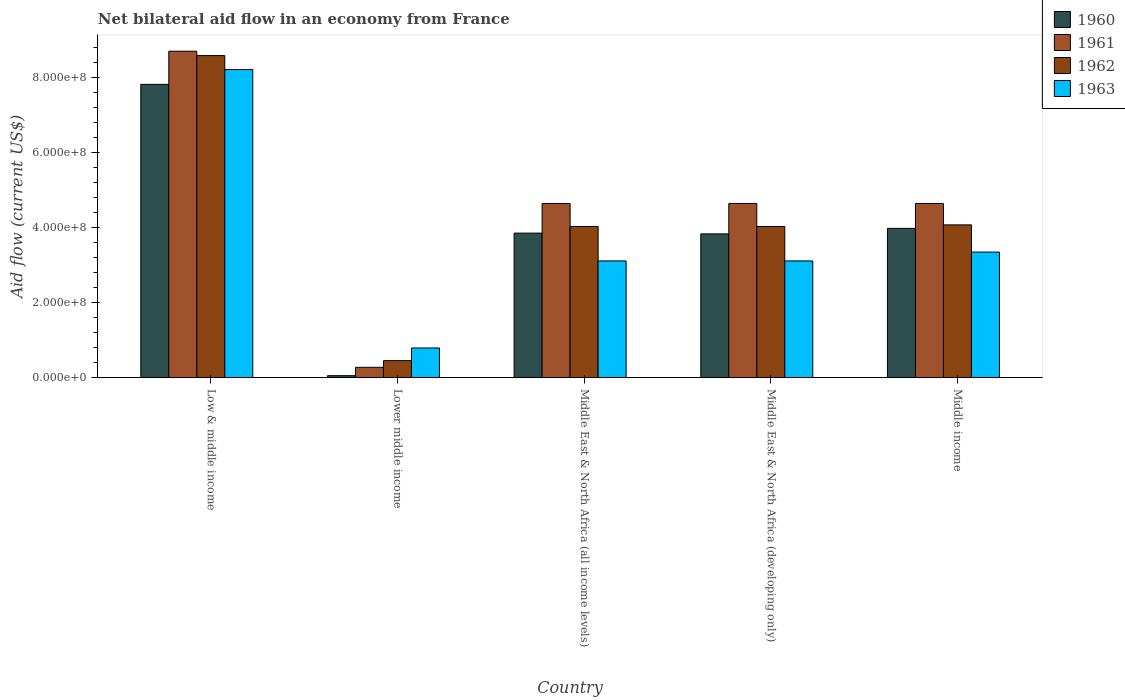How many groups of bars are there?
Make the answer very short. 5. Are the number of bars per tick equal to the number of legend labels?
Provide a succinct answer. Yes. How many bars are there on the 1st tick from the left?
Your response must be concise. 4. How many bars are there on the 1st tick from the right?
Offer a terse response. 4. What is the label of the 2nd group of bars from the left?
Provide a short and direct response. Lower middle income. In how many cases, is the number of bars for a given country not equal to the number of legend labels?
Your answer should be very brief. 0. What is the net bilateral aid flow in 1960 in Middle East & North Africa (developing only)?
Keep it short and to the point. 3.83e+08. Across all countries, what is the maximum net bilateral aid flow in 1961?
Your response must be concise. 8.70e+08. Across all countries, what is the minimum net bilateral aid flow in 1961?
Provide a short and direct response. 2.76e+07. In which country was the net bilateral aid flow in 1962 minimum?
Provide a short and direct response. Lower middle income. What is the total net bilateral aid flow in 1961 in the graph?
Ensure brevity in your answer.  2.29e+09. What is the difference between the net bilateral aid flow in 1960 in Lower middle income and that in Middle income?
Your answer should be compact. -3.92e+08. What is the difference between the net bilateral aid flow in 1963 in Low & middle income and the net bilateral aid flow in 1960 in Lower middle income?
Your response must be concise. 8.16e+08. What is the average net bilateral aid flow in 1961 per country?
Provide a succinct answer. 4.58e+08. What is the difference between the net bilateral aid flow of/in 1960 and net bilateral aid flow of/in 1963 in Middle East & North Africa (all income levels)?
Keep it short and to the point. 7.41e+07. What is the ratio of the net bilateral aid flow in 1962 in Low & middle income to that in Middle income?
Offer a terse response. 2.11. What is the difference between the highest and the second highest net bilateral aid flow in 1962?
Provide a succinct answer. 4.51e+08. What is the difference between the highest and the lowest net bilateral aid flow in 1960?
Provide a succinct answer. 7.76e+08. In how many countries, is the net bilateral aid flow in 1962 greater than the average net bilateral aid flow in 1962 taken over all countries?
Make the answer very short. 1. Is the sum of the net bilateral aid flow in 1961 in Middle East & North Africa (all income levels) and Middle East & North Africa (developing only) greater than the maximum net bilateral aid flow in 1962 across all countries?
Your answer should be compact. Yes. Is it the case that in every country, the sum of the net bilateral aid flow in 1963 and net bilateral aid flow in 1961 is greater than the sum of net bilateral aid flow in 1960 and net bilateral aid flow in 1962?
Make the answer very short. No. What is the difference between two consecutive major ticks on the Y-axis?
Make the answer very short. 2.00e+08. Are the values on the major ticks of Y-axis written in scientific E-notation?
Keep it short and to the point. Yes. Does the graph contain grids?
Provide a succinct answer. No. Where does the legend appear in the graph?
Your response must be concise. Top right. How are the legend labels stacked?
Your answer should be very brief. Vertical. What is the title of the graph?
Your answer should be compact. Net bilateral aid flow in an economy from France. What is the Aid flow (current US$) in 1960 in Low & middle income?
Your response must be concise. 7.82e+08. What is the Aid flow (current US$) of 1961 in Low & middle income?
Keep it short and to the point. 8.70e+08. What is the Aid flow (current US$) of 1962 in Low & middle income?
Make the answer very short. 8.58e+08. What is the Aid flow (current US$) in 1963 in Low & middle income?
Make the answer very short. 8.21e+08. What is the Aid flow (current US$) of 1960 in Lower middle income?
Make the answer very short. 5.30e+06. What is the Aid flow (current US$) of 1961 in Lower middle income?
Keep it short and to the point. 2.76e+07. What is the Aid flow (current US$) in 1962 in Lower middle income?
Offer a terse response. 4.54e+07. What is the Aid flow (current US$) in 1963 in Lower middle income?
Make the answer very short. 7.91e+07. What is the Aid flow (current US$) in 1960 in Middle East & North Africa (all income levels)?
Make the answer very short. 3.85e+08. What is the Aid flow (current US$) in 1961 in Middle East & North Africa (all income levels)?
Provide a short and direct response. 4.64e+08. What is the Aid flow (current US$) in 1962 in Middle East & North Africa (all income levels)?
Your answer should be very brief. 4.03e+08. What is the Aid flow (current US$) of 1963 in Middle East & North Africa (all income levels)?
Give a very brief answer. 3.11e+08. What is the Aid flow (current US$) in 1960 in Middle East & North Africa (developing only)?
Your response must be concise. 3.83e+08. What is the Aid flow (current US$) of 1961 in Middle East & North Africa (developing only)?
Give a very brief answer. 4.64e+08. What is the Aid flow (current US$) in 1962 in Middle East & North Africa (developing only)?
Your answer should be compact. 4.03e+08. What is the Aid flow (current US$) in 1963 in Middle East & North Africa (developing only)?
Provide a succinct answer. 3.11e+08. What is the Aid flow (current US$) of 1960 in Middle income?
Ensure brevity in your answer.  3.98e+08. What is the Aid flow (current US$) of 1961 in Middle income?
Ensure brevity in your answer.  4.64e+08. What is the Aid flow (current US$) in 1962 in Middle income?
Provide a succinct answer. 4.07e+08. What is the Aid flow (current US$) of 1963 in Middle income?
Offer a terse response. 3.35e+08. Across all countries, what is the maximum Aid flow (current US$) in 1960?
Your response must be concise. 7.82e+08. Across all countries, what is the maximum Aid flow (current US$) of 1961?
Offer a terse response. 8.70e+08. Across all countries, what is the maximum Aid flow (current US$) of 1962?
Offer a terse response. 8.58e+08. Across all countries, what is the maximum Aid flow (current US$) in 1963?
Your answer should be compact. 8.21e+08. Across all countries, what is the minimum Aid flow (current US$) in 1960?
Your answer should be very brief. 5.30e+06. Across all countries, what is the minimum Aid flow (current US$) of 1961?
Make the answer very short. 2.76e+07. Across all countries, what is the minimum Aid flow (current US$) of 1962?
Ensure brevity in your answer.  4.54e+07. Across all countries, what is the minimum Aid flow (current US$) of 1963?
Your answer should be very brief. 7.91e+07. What is the total Aid flow (current US$) of 1960 in the graph?
Make the answer very short. 1.95e+09. What is the total Aid flow (current US$) of 1961 in the graph?
Offer a very short reply. 2.29e+09. What is the total Aid flow (current US$) of 1962 in the graph?
Your answer should be very brief. 2.12e+09. What is the total Aid flow (current US$) in 1963 in the graph?
Offer a terse response. 1.86e+09. What is the difference between the Aid flow (current US$) in 1960 in Low & middle income and that in Lower middle income?
Keep it short and to the point. 7.76e+08. What is the difference between the Aid flow (current US$) in 1961 in Low & middle income and that in Lower middle income?
Keep it short and to the point. 8.42e+08. What is the difference between the Aid flow (current US$) of 1962 in Low & middle income and that in Lower middle income?
Your answer should be compact. 8.13e+08. What is the difference between the Aid flow (current US$) in 1963 in Low & middle income and that in Lower middle income?
Make the answer very short. 7.42e+08. What is the difference between the Aid flow (current US$) of 1960 in Low & middle income and that in Middle East & North Africa (all income levels)?
Provide a short and direct response. 3.96e+08. What is the difference between the Aid flow (current US$) in 1961 in Low & middle income and that in Middle East & North Africa (all income levels)?
Provide a short and direct response. 4.06e+08. What is the difference between the Aid flow (current US$) in 1962 in Low & middle income and that in Middle East & North Africa (all income levels)?
Offer a terse response. 4.55e+08. What is the difference between the Aid flow (current US$) of 1963 in Low & middle income and that in Middle East & North Africa (all income levels)?
Give a very brief answer. 5.10e+08. What is the difference between the Aid flow (current US$) in 1960 in Low & middle income and that in Middle East & North Africa (developing only)?
Your answer should be very brief. 3.98e+08. What is the difference between the Aid flow (current US$) of 1961 in Low & middle income and that in Middle East & North Africa (developing only)?
Your answer should be very brief. 4.06e+08. What is the difference between the Aid flow (current US$) in 1962 in Low & middle income and that in Middle East & North Africa (developing only)?
Provide a succinct answer. 4.55e+08. What is the difference between the Aid flow (current US$) in 1963 in Low & middle income and that in Middle East & North Africa (developing only)?
Your answer should be compact. 5.10e+08. What is the difference between the Aid flow (current US$) of 1960 in Low & middle income and that in Middle income?
Offer a very short reply. 3.84e+08. What is the difference between the Aid flow (current US$) in 1961 in Low & middle income and that in Middle income?
Provide a short and direct response. 4.06e+08. What is the difference between the Aid flow (current US$) of 1962 in Low & middle income and that in Middle income?
Make the answer very short. 4.51e+08. What is the difference between the Aid flow (current US$) of 1963 in Low & middle income and that in Middle income?
Offer a terse response. 4.86e+08. What is the difference between the Aid flow (current US$) in 1960 in Lower middle income and that in Middle East & North Africa (all income levels)?
Keep it short and to the point. -3.80e+08. What is the difference between the Aid flow (current US$) of 1961 in Lower middle income and that in Middle East & North Africa (all income levels)?
Offer a very short reply. -4.37e+08. What is the difference between the Aid flow (current US$) of 1962 in Lower middle income and that in Middle East & North Africa (all income levels)?
Provide a short and direct response. -3.58e+08. What is the difference between the Aid flow (current US$) of 1963 in Lower middle income and that in Middle East & North Africa (all income levels)?
Your response must be concise. -2.32e+08. What is the difference between the Aid flow (current US$) in 1960 in Lower middle income and that in Middle East & North Africa (developing only)?
Keep it short and to the point. -3.78e+08. What is the difference between the Aid flow (current US$) in 1961 in Lower middle income and that in Middle East & North Africa (developing only)?
Offer a very short reply. -4.37e+08. What is the difference between the Aid flow (current US$) of 1962 in Lower middle income and that in Middle East & North Africa (developing only)?
Your answer should be very brief. -3.58e+08. What is the difference between the Aid flow (current US$) of 1963 in Lower middle income and that in Middle East & North Africa (developing only)?
Your answer should be very brief. -2.32e+08. What is the difference between the Aid flow (current US$) of 1960 in Lower middle income and that in Middle income?
Keep it short and to the point. -3.92e+08. What is the difference between the Aid flow (current US$) in 1961 in Lower middle income and that in Middle income?
Ensure brevity in your answer.  -4.37e+08. What is the difference between the Aid flow (current US$) of 1962 in Lower middle income and that in Middle income?
Keep it short and to the point. -3.62e+08. What is the difference between the Aid flow (current US$) in 1963 in Lower middle income and that in Middle income?
Offer a terse response. -2.56e+08. What is the difference between the Aid flow (current US$) in 1963 in Middle East & North Africa (all income levels) and that in Middle East & North Africa (developing only)?
Your response must be concise. 0. What is the difference between the Aid flow (current US$) of 1960 in Middle East & North Africa (all income levels) and that in Middle income?
Your response must be concise. -1.26e+07. What is the difference between the Aid flow (current US$) of 1961 in Middle East & North Africa (all income levels) and that in Middle income?
Ensure brevity in your answer.  0. What is the difference between the Aid flow (current US$) of 1962 in Middle East & North Africa (all income levels) and that in Middle income?
Offer a terse response. -4.20e+06. What is the difference between the Aid flow (current US$) of 1963 in Middle East & North Africa (all income levels) and that in Middle income?
Provide a succinct answer. -2.36e+07. What is the difference between the Aid flow (current US$) of 1960 in Middle East & North Africa (developing only) and that in Middle income?
Your answer should be very brief. -1.46e+07. What is the difference between the Aid flow (current US$) of 1961 in Middle East & North Africa (developing only) and that in Middle income?
Make the answer very short. 0. What is the difference between the Aid flow (current US$) in 1962 in Middle East & North Africa (developing only) and that in Middle income?
Your response must be concise. -4.20e+06. What is the difference between the Aid flow (current US$) in 1963 in Middle East & North Africa (developing only) and that in Middle income?
Provide a succinct answer. -2.36e+07. What is the difference between the Aid flow (current US$) of 1960 in Low & middle income and the Aid flow (current US$) of 1961 in Lower middle income?
Offer a terse response. 7.54e+08. What is the difference between the Aid flow (current US$) of 1960 in Low & middle income and the Aid flow (current US$) of 1962 in Lower middle income?
Give a very brief answer. 7.36e+08. What is the difference between the Aid flow (current US$) in 1960 in Low & middle income and the Aid flow (current US$) in 1963 in Lower middle income?
Ensure brevity in your answer.  7.02e+08. What is the difference between the Aid flow (current US$) of 1961 in Low & middle income and the Aid flow (current US$) of 1962 in Lower middle income?
Offer a terse response. 8.25e+08. What is the difference between the Aid flow (current US$) of 1961 in Low & middle income and the Aid flow (current US$) of 1963 in Lower middle income?
Offer a terse response. 7.91e+08. What is the difference between the Aid flow (current US$) of 1962 in Low & middle income and the Aid flow (current US$) of 1963 in Lower middle income?
Make the answer very short. 7.79e+08. What is the difference between the Aid flow (current US$) in 1960 in Low & middle income and the Aid flow (current US$) in 1961 in Middle East & North Africa (all income levels)?
Your answer should be compact. 3.17e+08. What is the difference between the Aid flow (current US$) of 1960 in Low & middle income and the Aid flow (current US$) of 1962 in Middle East & North Africa (all income levels)?
Offer a terse response. 3.79e+08. What is the difference between the Aid flow (current US$) of 1960 in Low & middle income and the Aid flow (current US$) of 1963 in Middle East & North Africa (all income levels)?
Offer a very short reply. 4.70e+08. What is the difference between the Aid flow (current US$) of 1961 in Low & middle income and the Aid flow (current US$) of 1962 in Middle East & North Africa (all income levels)?
Keep it short and to the point. 4.67e+08. What is the difference between the Aid flow (current US$) in 1961 in Low & middle income and the Aid flow (current US$) in 1963 in Middle East & North Africa (all income levels)?
Give a very brief answer. 5.59e+08. What is the difference between the Aid flow (current US$) in 1962 in Low & middle income and the Aid flow (current US$) in 1963 in Middle East & North Africa (all income levels)?
Offer a terse response. 5.47e+08. What is the difference between the Aid flow (current US$) of 1960 in Low & middle income and the Aid flow (current US$) of 1961 in Middle East & North Africa (developing only)?
Your answer should be compact. 3.17e+08. What is the difference between the Aid flow (current US$) in 1960 in Low & middle income and the Aid flow (current US$) in 1962 in Middle East & North Africa (developing only)?
Your answer should be compact. 3.79e+08. What is the difference between the Aid flow (current US$) in 1960 in Low & middle income and the Aid flow (current US$) in 1963 in Middle East & North Africa (developing only)?
Ensure brevity in your answer.  4.70e+08. What is the difference between the Aid flow (current US$) of 1961 in Low & middle income and the Aid flow (current US$) of 1962 in Middle East & North Africa (developing only)?
Your answer should be very brief. 4.67e+08. What is the difference between the Aid flow (current US$) of 1961 in Low & middle income and the Aid flow (current US$) of 1963 in Middle East & North Africa (developing only)?
Give a very brief answer. 5.59e+08. What is the difference between the Aid flow (current US$) of 1962 in Low & middle income and the Aid flow (current US$) of 1963 in Middle East & North Africa (developing only)?
Give a very brief answer. 5.47e+08. What is the difference between the Aid flow (current US$) in 1960 in Low & middle income and the Aid flow (current US$) in 1961 in Middle income?
Your response must be concise. 3.17e+08. What is the difference between the Aid flow (current US$) in 1960 in Low & middle income and the Aid flow (current US$) in 1962 in Middle income?
Offer a very short reply. 3.74e+08. What is the difference between the Aid flow (current US$) of 1960 in Low & middle income and the Aid flow (current US$) of 1963 in Middle income?
Your answer should be compact. 4.47e+08. What is the difference between the Aid flow (current US$) in 1961 in Low & middle income and the Aid flow (current US$) in 1962 in Middle income?
Give a very brief answer. 4.63e+08. What is the difference between the Aid flow (current US$) in 1961 in Low & middle income and the Aid flow (current US$) in 1963 in Middle income?
Offer a very short reply. 5.35e+08. What is the difference between the Aid flow (current US$) in 1962 in Low & middle income and the Aid flow (current US$) in 1963 in Middle income?
Offer a very short reply. 5.24e+08. What is the difference between the Aid flow (current US$) of 1960 in Lower middle income and the Aid flow (current US$) of 1961 in Middle East & North Africa (all income levels)?
Offer a very short reply. -4.59e+08. What is the difference between the Aid flow (current US$) of 1960 in Lower middle income and the Aid flow (current US$) of 1962 in Middle East & North Africa (all income levels)?
Keep it short and to the point. -3.98e+08. What is the difference between the Aid flow (current US$) of 1960 in Lower middle income and the Aid flow (current US$) of 1963 in Middle East & North Africa (all income levels)?
Give a very brief answer. -3.06e+08. What is the difference between the Aid flow (current US$) in 1961 in Lower middle income and the Aid flow (current US$) in 1962 in Middle East & North Africa (all income levels)?
Offer a very short reply. -3.75e+08. What is the difference between the Aid flow (current US$) in 1961 in Lower middle income and the Aid flow (current US$) in 1963 in Middle East & North Africa (all income levels)?
Your answer should be compact. -2.84e+08. What is the difference between the Aid flow (current US$) in 1962 in Lower middle income and the Aid flow (current US$) in 1963 in Middle East & North Africa (all income levels)?
Provide a short and direct response. -2.66e+08. What is the difference between the Aid flow (current US$) of 1960 in Lower middle income and the Aid flow (current US$) of 1961 in Middle East & North Africa (developing only)?
Your answer should be compact. -4.59e+08. What is the difference between the Aid flow (current US$) in 1960 in Lower middle income and the Aid flow (current US$) in 1962 in Middle East & North Africa (developing only)?
Your answer should be very brief. -3.98e+08. What is the difference between the Aid flow (current US$) of 1960 in Lower middle income and the Aid flow (current US$) of 1963 in Middle East & North Africa (developing only)?
Offer a very short reply. -3.06e+08. What is the difference between the Aid flow (current US$) in 1961 in Lower middle income and the Aid flow (current US$) in 1962 in Middle East & North Africa (developing only)?
Ensure brevity in your answer.  -3.75e+08. What is the difference between the Aid flow (current US$) in 1961 in Lower middle income and the Aid flow (current US$) in 1963 in Middle East & North Africa (developing only)?
Provide a succinct answer. -2.84e+08. What is the difference between the Aid flow (current US$) of 1962 in Lower middle income and the Aid flow (current US$) of 1963 in Middle East & North Africa (developing only)?
Provide a succinct answer. -2.66e+08. What is the difference between the Aid flow (current US$) in 1960 in Lower middle income and the Aid flow (current US$) in 1961 in Middle income?
Ensure brevity in your answer.  -4.59e+08. What is the difference between the Aid flow (current US$) of 1960 in Lower middle income and the Aid flow (current US$) of 1962 in Middle income?
Make the answer very short. -4.02e+08. What is the difference between the Aid flow (current US$) of 1960 in Lower middle income and the Aid flow (current US$) of 1963 in Middle income?
Your answer should be very brief. -3.29e+08. What is the difference between the Aid flow (current US$) in 1961 in Lower middle income and the Aid flow (current US$) in 1962 in Middle income?
Your answer should be compact. -3.80e+08. What is the difference between the Aid flow (current US$) of 1961 in Lower middle income and the Aid flow (current US$) of 1963 in Middle income?
Your response must be concise. -3.07e+08. What is the difference between the Aid flow (current US$) in 1962 in Lower middle income and the Aid flow (current US$) in 1963 in Middle income?
Your answer should be compact. -2.89e+08. What is the difference between the Aid flow (current US$) in 1960 in Middle East & North Africa (all income levels) and the Aid flow (current US$) in 1961 in Middle East & North Africa (developing only)?
Provide a succinct answer. -7.90e+07. What is the difference between the Aid flow (current US$) in 1960 in Middle East & North Africa (all income levels) and the Aid flow (current US$) in 1962 in Middle East & North Africa (developing only)?
Your answer should be very brief. -1.78e+07. What is the difference between the Aid flow (current US$) in 1960 in Middle East & North Africa (all income levels) and the Aid flow (current US$) in 1963 in Middle East & North Africa (developing only)?
Offer a very short reply. 7.41e+07. What is the difference between the Aid flow (current US$) of 1961 in Middle East & North Africa (all income levels) and the Aid flow (current US$) of 1962 in Middle East & North Africa (developing only)?
Offer a terse response. 6.12e+07. What is the difference between the Aid flow (current US$) of 1961 in Middle East & North Africa (all income levels) and the Aid flow (current US$) of 1963 in Middle East & North Africa (developing only)?
Make the answer very short. 1.53e+08. What is the difference between the Aid flow (current US$) of 1962 in Middle East & North Africa (all income levels) and the Aid flow (current US$) of 1963 in Middle East & North Africa (developing only)?
Ensure brevity in your answer.  9.19e+07. What is the difference between the Aid flow (current US$) in 1960 in Middle East & North Africa (all income levels) and the Aid flow (current US$) in 1961 in Middle income?
Provide a short and direct response. -7.90e+07. What is the difference between the Aid flow (current US$) in 1960 in Middle East & North Africa (all income levels) and the Aid flow (current US$) in 1962 in Middle income?
Ensure brevity in your answer.  -2.20e+07. What is the difference between the Aid flow (current US$) of 1960 in Middle East & North Africa (all income levels) and the Aid flow (current US$) of 1963 in Middle income?
Offer a terse response. 5.05e+07. What is the difference between the Aid flow (current US$) of 1961 in Middle East & North Africa (all income levels) and the Aid flow (current US$) of 1962 in Middle income?
Make the answer very short. 5.70e+07. What is the difference between the Aid flow (current US$) of 1961 in Middle East & North Africa (all income levels) and the Aid flow (current US$) of 1963 in Middle income?
Your answer should be very brief. 1.30e+08. What is the difference between the Aid flow (current US$) of 1962 in Middle East & North Africa (all income levels) and the Aid flow (current US$) of 1963 in Middle income?
Your answer should be very brief. 6.83e+07. What is the difference between the Aid flow (current US$) of 1960 in Middle East & North Africa (developing only) and the Aid flow (current US$) of 1961 in Middle income?
Ensure brevity in your answer.  -8.10e+07. What is the difference between the Aid flow (current US$) in 1960 in Middle East & North Africa (developing only) and the Aid flow (current US$) in 1962 in Middle income?
Your response must be concise. -2.40e+07. What is the difference between the Aid flow (current US$) in 1960 in Middle East & North Africa (developing only) and the Aid flow (current US$) in 1963 in Middle income?
Keep it short and to the point. 4.85e+07. What is the difference between the Aid flow (current US$) in 1961 in Middle East & North Africa (developing only) and the Aid flow (current US$) in 1962 in Middle income?
Offer a very short reply. 5.70e+07. What is the difference between the Aid flow (current US$) of 1961 in Middle East & North Africa (developing only) and the Aid flow (current US$) of 1963 in Middle income?
Offer a very short reply. 1.30e+08. What is the difference between the Aid flow (current US$) in 1962 in Middle East & North Africa (developing only) and the Aid flow (current US$) in 1963 in Middle income?
Your answer should be compact. 6.83e+07. What is the average Aid flow (current US$) of 1960 per country?
Your response must be concise. 3.91e+08. What is the average Aid flow (current US$) of 1961 per country?
Your response must be concise. 4.58e+08. What is the average Aid flow (current US$) in 1962 per country?
Ensure brevity in your answer.  4.23e+08. What is the average Aid flow (current US$) in 1963 per country?
Make the answer very short. 3.71e+08. What is the difference between the Aid flow (current US$) in 1960 and Aid flow (current US$) in 1961 in Low & middle income?
Give a very brief answer. -8.84e+07. What is the difference between the Aid flow (current US$) of 1960 and Aid flow (current US$) of 1962 in Low & middle income?
Offer a terse response. -7.67e+07. What is the difference between the Aid flow (current US$) in 1960 and Aid flow (current US$) in 1963 in Low & middle income?
Your answer should be compact. -3.95e+07. What is the difference between the Aid flow (current US$) in 1961 and Aid flow (current US$) in 1962 in Low & middle income?
Make the answer very short. 1.17e+07. What is the difference between the Aid flow (current US$) of 1961 and Aid flow (current US$) of 1963 in Low & middle income?
Offer a very short reply. 4.89e+07. What is the difference between the Aid flow (current US$) of 1962 and Aid flow (current US$) of 1963 in Low & middle income?
Offer a terse response. 3.72e+07. What is the difference between the Aid flow (current US$) of 1960 and Aid flow (current US$) of 1961 in Lower middle income?
Make the answer very short. -2.23e+07. What is the difference between the Aid flow (current US$) in 1960 and Aid flow (current US$) in 1962 in Lower middle income?
Ensure brevity in your answer.  -4.01e+07. What is the difference between the Aid flow (current US$) of 1960 and Aid flow (current US$) of 1963 in Lower middle income?
Give a very brief answer. -7.38e+07. What is the difference between the Aid flow (current US$) of 1961 and Aid flow (current US$) of 1962 in Lower middle income?
Give a very brief answer. -1.78e+07. What is the difference between the Aid flow (current US$) of 1961 and Aid flow (current US$) of 1963 in Lower middle income?
Make the answer very short. -5.15e+07. What is the difference between the Aid flow (current US$) in 1962 and Aid flow (current US$) in 1963 in Lower middle income?
Your answer should be compact. -3.37e+07. What is the difference between the Aid flow (current US$) of 1960 and Aid flow (current US$) of 1961 in Middle East & North Africa (all income levels)?
Your answer should be very brief. -7.90e+07. What is the difference between the Aid flow (current US$) in 1960 and Aid flow (current US$) in 1962 in Middle East & North Africa (all income levels)?
Make the answer very short. -1.78e+07. What is the difference between the Aid flow (current US$) in 1960 and Aid flow (current US$) in 1963 in Middle East & North Africa (all income levels)?
Your answer should be compact. 7.41e+07. What is the difference between the Aid flow (current US$) of 1961 and Aid flow (current US$) of 1962 in Middle East & North Africa (all income levels)?
Provide a succinct answer. 6.12e+07. What is the difference between the Aid flow (current US$) of 1961 and Aid flow (current US$) of 1963 in Middle East & North Africa (all income levels)?
Give a very brief answer. 1.53e+08. What is the difference between the Aid flow (current US$) in 1962 and Aid flow (current US$) in 1963 in Middle East & North Africa (all income levels)?
Make the answer very short. 9.19e+07. What is the difference between the Aid flow (current US$) in 1960 and Aid flow (current US$) in 1961 in Middle East & North Africa (developing only)?
Your answer should be compact. -8.10e+07. What is the difference between the Aid flow (current US$) in 1960 and Aid flow (current US$) in 1962 in Middle East & North Africa (developing only)?
Provide a short and direct response. -1.98e+07. What is the difference between the Aid flow (current US$) of 1960 and Aid flow (current US$) of 1963 in Middle East & North Africa (developing only)?
Ensure brevity in your answer.  7.21e+07. What is the difference between the Aid flow (current US$) of 1961 and Aid flow (current US$) of 1962 in Middle East & North Africa (developing only)?
Your response must be concise. 6.12e+07. What is the difference between the Aid flow (current US$) of 1961 and Aid flow (current US$) of 1963 in Middle East & North Africa (developing only)?
Ensure brevity in your answer.  1.53e+08. What is the difference between the Aid flow (current US$) of 1962 and Aid flow (current US$) of 1963 in Middle East & North Africa (developing only)?
Offer a terse response. 9.19e+07. What is the difference between the Aid flow (current US$) of 1960 and Aid flow (current US$) of 1961 in Middle income?
Offer a terse response. -6.64e+07. What is the difference between the Aid flow (current US$) in 1960 and Aid flow (current US$) in 1962 in Middle income?
Make the answer very short. -9.40e+06. What is the difference between the Aid flow (current US$) in 1960 and Aid flow (current US$) in 1963 in Middle income?
Give a very brief answer. 6.31e+07. What is the difference between the Aid flow (current US$) in 1961 and Aid flow (current US$) in 1962 in Middle income?
Make the answer very short. 5.70e+07. What is the difference between the Aid flow (current US$) of 1961 and Aid flow (current US$) of 1963 in Middle income?
Make the answer very short. 1.30e+08. What is the difference between the Aid flow (current US$) in 1962 and Aid flow (current US$) in 1963 in Middle income?
Your response must be concise. 7.25e+07. What is the ratio of the Aid flow (current US$) of 1960 in Low & middle income to that in Lower middle income?
Offer a very short reply. 147.47. What is the ratio of the Aid flow (current US$) of 1961 in Low & middle income to that in Lower middle income?
Your answer should be compact. 31.52. What is the ratio of the Aid flow (current US$) of 1962 in Low & middle income to that in Lower middle income?
Make the answer very short. 18.91. What is the ratio of the Aid flow (current US$) of 1963 in Low & middle income to that in Lower middle income?
Offer a very short reply. 10.38. What is the ratio of the Aid flow (current US$) of 1960 in Low & middle income to that in Middle East & North Africa (all income levels)?
Your answer should be compact. 2.03. What is the ratio of the Aid flow (current US$) of 1961 in Low & middle income to that in Middle East & North Africa (all income levels)?
Offer a terse response. 1.87. What is the ratio of the Aid flow (current US$) in 1962 in Low & middle income to that in Middle East & North Africa (all income levels)?
Ensure brevity in your answer.  2.13. What is the ratio of the Aid flow (current US$) of 1963 in Low & middle income to that in Middle East & North Africa (all income levels)?
Your answer should be very brief. 2.64. What is the ratio of the Aid flow (current US$) of 1960 in Low & middle income to that in Middle East & North Africa (developing only)?
Offer a very short reply. 2.04. What is the ratio of the Aid flow (current US$) of 1961 in Low & middle income to that in Middle East & North Africa (developing only)?
Make the answer very short. 1.87. What is the ratio of the Aid flow (current US$) of 1962 in Low & middle income to that in Middle East & North Africa (developing only)?
Ensure brevity in your answer.  2.13. What is the ratio of the Aid flow (current US$) of 1963 in Low & middle income to that in Middle East & North Africa (developing only)?
Offer a terse response. 2.64. What is the ratio of the Aid flow (current US$) in 1960 in Low & middle income to that in Middle income?
Give a very brief answer. 1.96. What is the ratio of the Aid flow (current US$) in 1961 in Low & middle income to that in Middle income?
Your response must be concise. 1.87. What is the ratio of the Aid flow (current US$) of 1962 in Low & middle income to that in Middle income?
Your answer should be very brief. 2.11. What is the ratio of the Aid flow (current US$) in 1963 in Low & middle income to that in Middle income?
Offer a very short reply. 2.45. What is the ratio of the Aid flow (current US$) in 1960 in Lower middle income to that in Middle East & North Africa (all income levels)?
Your response must be concise. 0.01. What is the ratio of the Aid flow (current US$) of 1961 in Lower middle income to that in Middle East & North Africa (all income levels)?
Your answer should be very brief. 0.06. What is the ratio of the Aid flow (current US$) of 1962 in Lower middle income to that in Middle East & North Africa (all income levels)?
Give a very brief answer. 0.11. What is the ratio of the Aid flow (current US$) of 1963 in Lower middle income to that in Middle East & North Africa (all income levels)?
Your response must be concise. 0.25. What is the ratio of the Aid flow (current US$) of 1960 in Lower middle income to that in Middle East & North Africa (developing only)?
Your response must be concise. 0.01. What is the ratio of the Aid flow (current US$) in 1961 in Lower middle income to that in Middle East & North Africa (developing only)?
Offer a very short reply. 0.06. What is the ratio of the Aid flow (current US$) of 1962 in Lower middle income to that in Middle East & North Africa (developing only)?
Keep it short and to the point. 0.11. What is the ratio of the Aid flow (current US$) in 1963 in Lower middle income to that in Middle East & North Africa (developing only)?
Give a very brief answer. 0.25. What is the ratio of the Aid flow (current US$) in 1960 in Lower middle income to that in Middle income?
Your response must be concise. 0.01. What is the ratio of the Aid flow (current US$) of 1961 in Lower middle income to that in Middle income?
Give a very brief answer. 0.06. What is the ratio of the Aid flow (current US$) of 1962 in Lower middle income to that in Middle income?
Give a very brief answer. 0.11. What is the ratio of the Aid flow (current US$) in 1963 in Lower middle income to that in Middle income?
Offer a terse response. 0.24. What is the ratio of the Aid flow (current US$) of 1960 in Middle East & North Africa (all income levels) to that in Middle East & North Africa (developing only)?
Offer a very short reply. 1.01. What is the ratio of the Aid flow (current US$) in 1962 in Middle East & North Africa (all income levels) to that in Middle East & North Africa (developing only)?
Make the answer very short. 1. What is the ratio of the Aid flow (current US$) in 1963 in Middle East & North Africa (all income levels) to that in Middle East & North Africa (developing only)?
Give a very brief answer. 1. What is the ratio of the Aid flow (current US$) of 1960 in Middle East & North Africa (all income levels) to that in Middle income?
Provide a succinct answer. 0.97. What is the ratio of the Aid flow (current US$) in 1962 in Middle East & North Africa (all income levels) to that in Middle income?
Ensure brevity in your answer.  0.99. What is the ratio of the Aid flow (current US$) of 1963 in Middle East & North Africa (all income levels) to that in Middle income?
Provide a short and direct response. 0.93. What is the ratio of the Aid flow (current US$) in 1960 in Middle East & North Africa (developing only) to that in Middle income?
Your response must be concise. 0.96. What is the ratio of the Aid flow (current US$) in 1961 in Middle East & North Africa (developing only) to that in Middle income?
Provide a short and direct response. 1. What is the ratio of the Aid flow (current US$) in 1963 in Middle East & North Africa (developing only) to that in Middle income?
Provide a short and direct response. 0.93. What is the difference between the highest and the second highest Aid flow (current US$) of 1960?
Ensure brevity in your answer.  3.84e+08. What is the difference between the highest and the second highest Aid flow (current US$) in 1961?
Make the answer very short. 4.06e+08. What is the difference between the highest and the second highest Aid flow (current US$) in 1962?
Offer a very short reply. 4.51e+08. What is the difference between the highest and the second highest Aid flow (current US$) of 1963?
Give a very brief answer. 4.86e+08. What is the difference between the highest and the lowest Aid flow (current US$) of 1960?
Your response must be concise. 7.76e+08. What is the difference between the highest and the lowest Aid flow (current US$) of 1961?
Your response must be concise. 8.42e+08. What is the difference between the highest and the lowest Aid flow (current US$) in 1962?
Ensure brevity in your answer.  8.13e+08. What is the difference between the highest and the lowest Aid flow (current US$) of 1963?
Make the answer very short. 7.42e+08. 